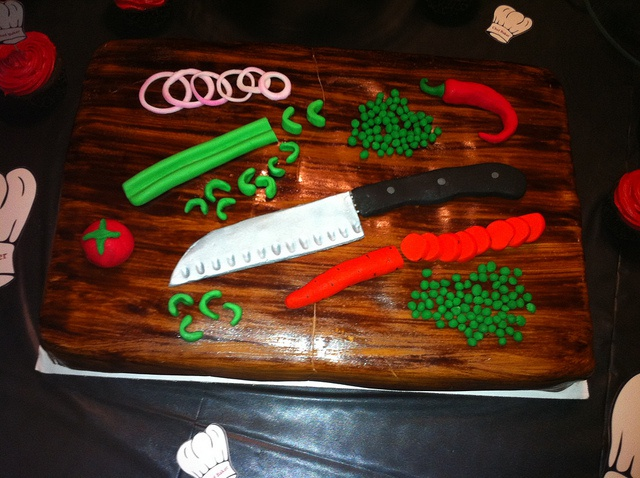Describe the objects in this image and their specific colors. I can see cake in black, maroon, and brown tones and knife in black, white, darkgray, and lightblue tones in this image. 